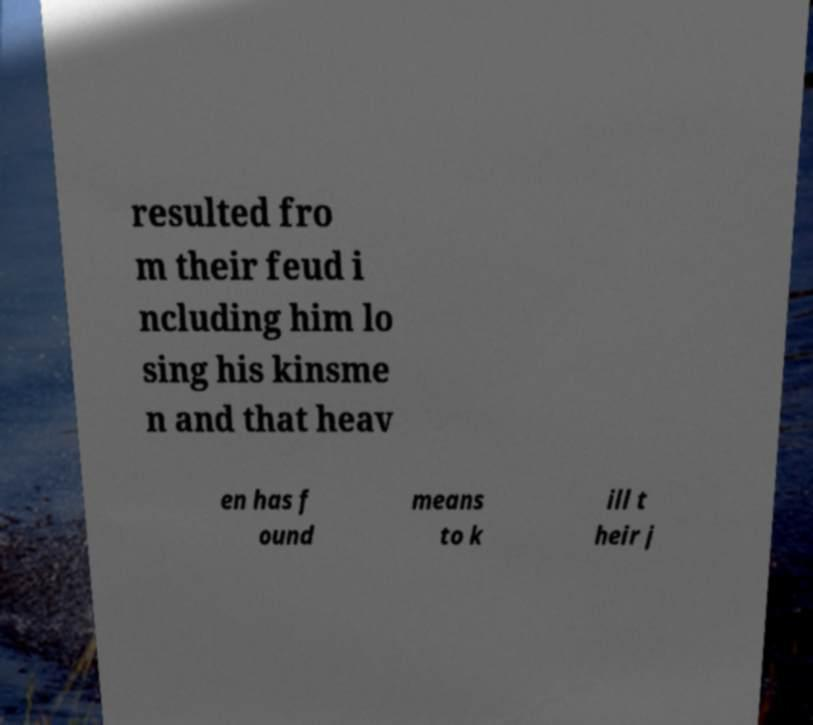Can you accurately transcribe the text from the provided image for me? resulted fro m their feud i ncluding him lo sing his kinsme n and that heav en has f ound means to k ill t heir j 